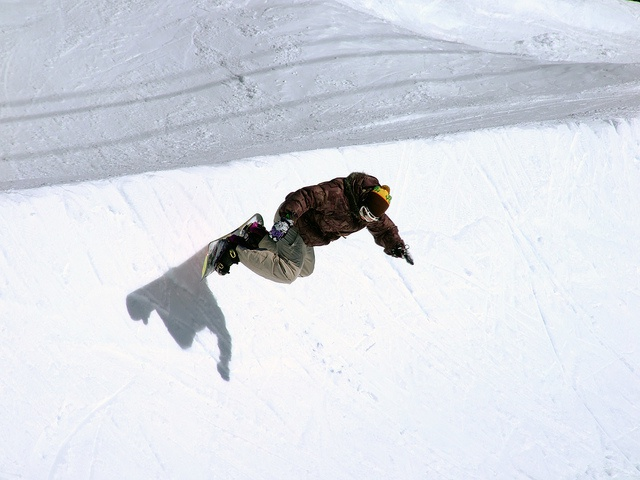Describe the objects in this image and their specific colors. I can see people in lightgray, black, gray, maroon, and darkgray tones and snowboard in lightgray, gray, black, and darkgray tones in this image. 